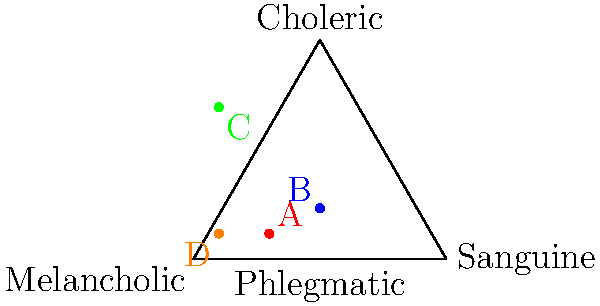In the quaternary plot representing the four humors theory, which point most likely represents a person with a predominantly melancholic temperament? To answer this question, we need to understand the quaternary plot and the four humors theory:

1. The quaternary plot is divided into four regions, each representing one of the four humors: Sanguine, Choleric, Melancholic, and Phlegmatic.

2. The closer a point is to a corner, the more dominant that humor is in the person's temperament.

3. The Melancholic humor is represented by the bottom-left corner of the triangle.

4. We need to identify which point (A, B, C, or D) is closest to the Melancholic corner.

Analyzing the points:
- Point A (red) is closer to the Sanguine corner.
- Point B (blue) is roughly in the center, indicating a balance of humors.
- Point C (green) is clearly closest to the Melancholic corner.
- Point D (orange) is closest to the Phlegmatic corner.

Therefore, point C (green) most likely represents a person with a predominantly melancholic temperament.
Answer: C 